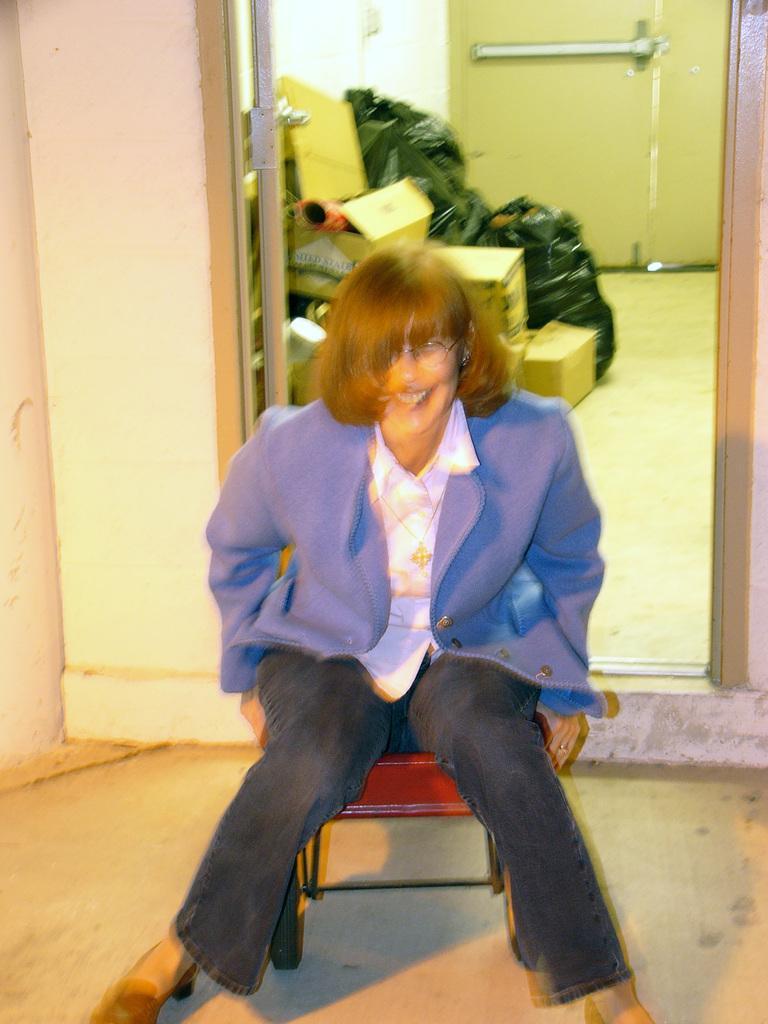In one or two sentences, can you explain what this image depicts? In this picture we can see a woman sitting on a chair. There are few covers,boxes and a door in the background. 